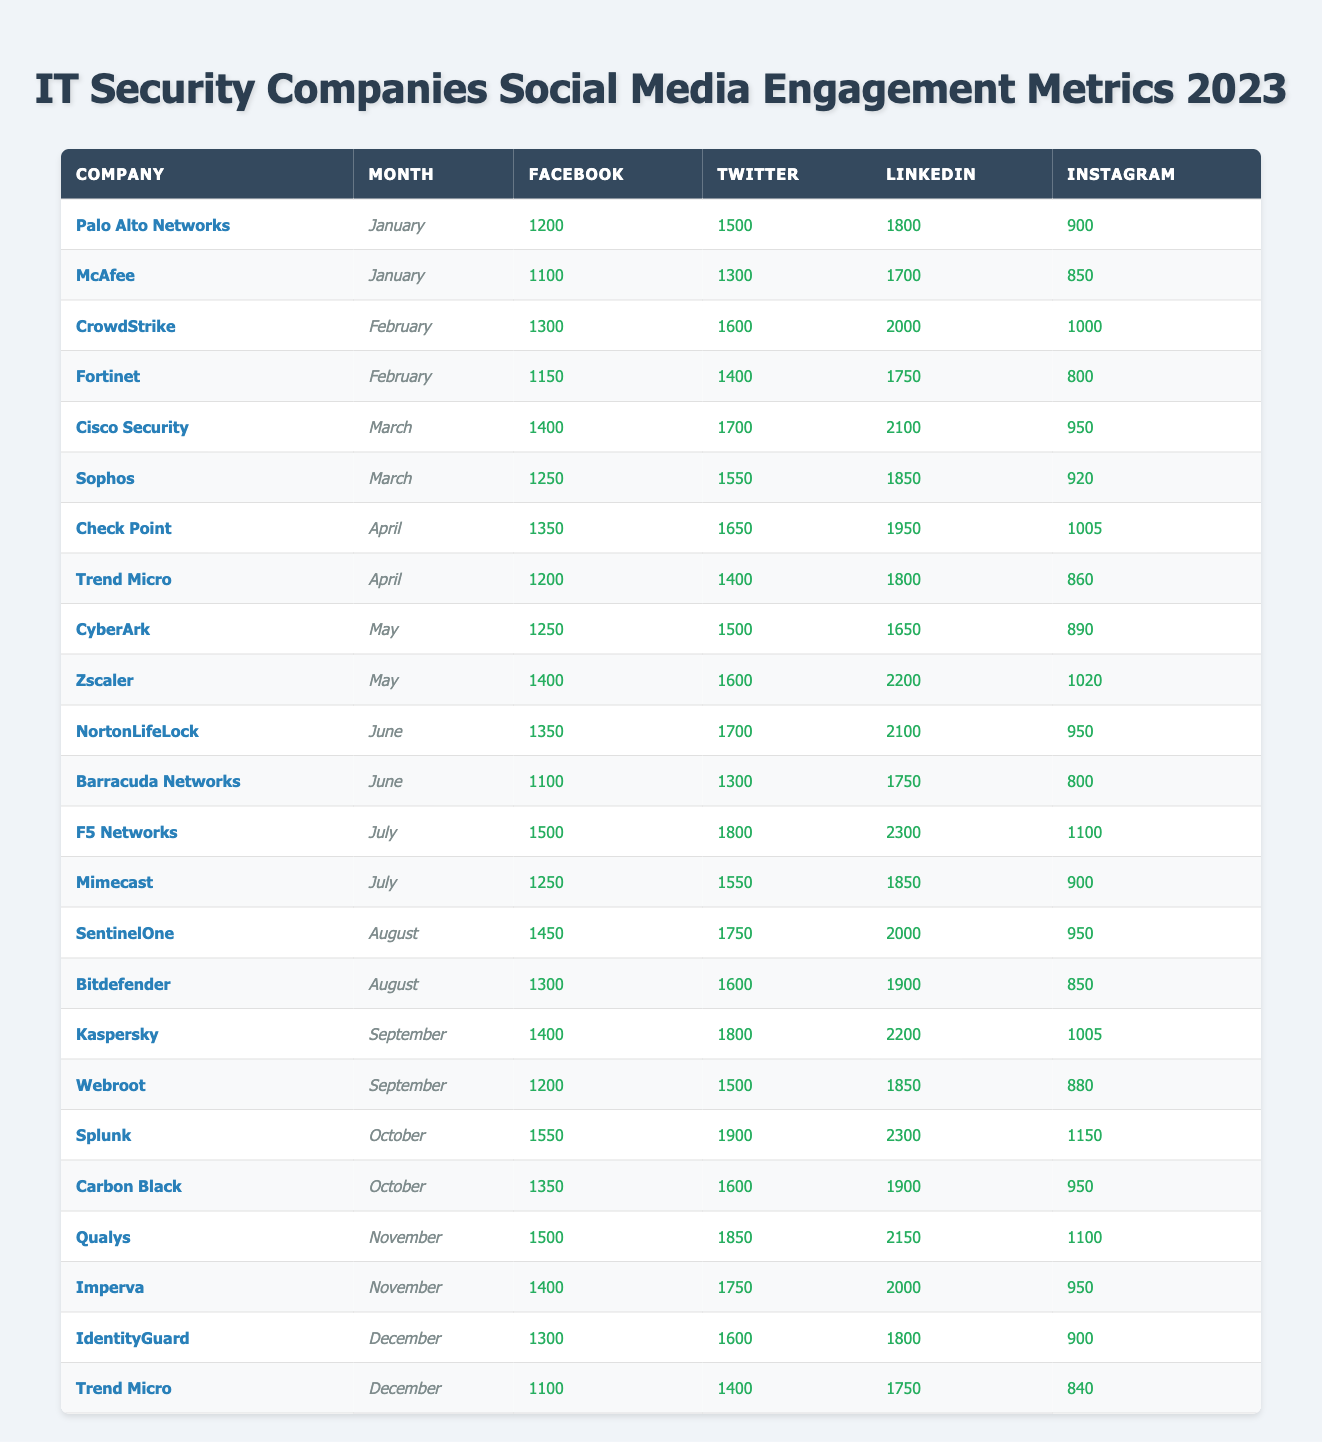What was the Facebook engagement for Palo Alto Networks in January? Palo Alto Networks' Facebook engagement in January is listed as 1200 in the table.
Answer: 1200 Which company had the highest Twitter engagement in March? In March, Cisco Security had a Twitter engagement of 1700, while Sophos had 1550. Therefore, Cisco Security had the highest Twitter engagement that month.
Answer: Cisco Security What is the total LinkedIn engagement for CrowdStrike and Fortinet in February? CrowdStrike's LinkedIn engagement in February was 2000 and Fortinet's was 1750. Adding these two values together gives 2000 + 1750 = 3750.
Answer: 3750 Did any company have more than 2000 engagements on LinkedIn in May? In May, Zscaler had 2200 LinkedIn engagements, which is more than 2000. Hence, the answer is yes.
Answer: Yes What was the average Facebook engagement for Trend Micro over the months listed? Trend Micro's Facebook engagement in April was 1200 and in December was 1100. The average is calculated by adding these values, which gives 1200 + 1100 = 2300. Dividing this by the number of months (2) gives an average of 2300 / 2 = 1150.
Answer: 1150 Which company had the least Instagram engagement in November? In November, Imperva had 950 Instagram engagements while Qualys had 1100. Therefore, Imperva had the least engagement on Instagram that month.
Answer: Imperva What is the difference in Facebook engagement between F5 Networks and Barracuda Networks in July? In July, F5 Networks had 1500 Facebook engagements and Barracuda Networks had 1100. The difference is calculated by subtracting Barracuda's engagement from F5's: 1500 - 1100 = 400.
Answer: 400 Which month had the highest overall LinkedIn engagement, and what was the total? By reviewing the table, in July, F5 Networks had 2300 engagements on LinkedIn, which is the highest value recorded. Therefore, July had the highest engagement on LinkedIn, totaling 2300.
Answer: July, 2300 